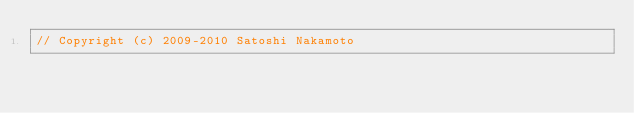<code> <loc_0><loc_0><loc_500><loc_500><_C++_>// Copyright (c) 2009-2010 Satoshi Nakamoto</code> 